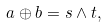<formula> <loc_0><loc_0><loc_500><loc_500>a \oplus b = s \wedge t ,</formula> 